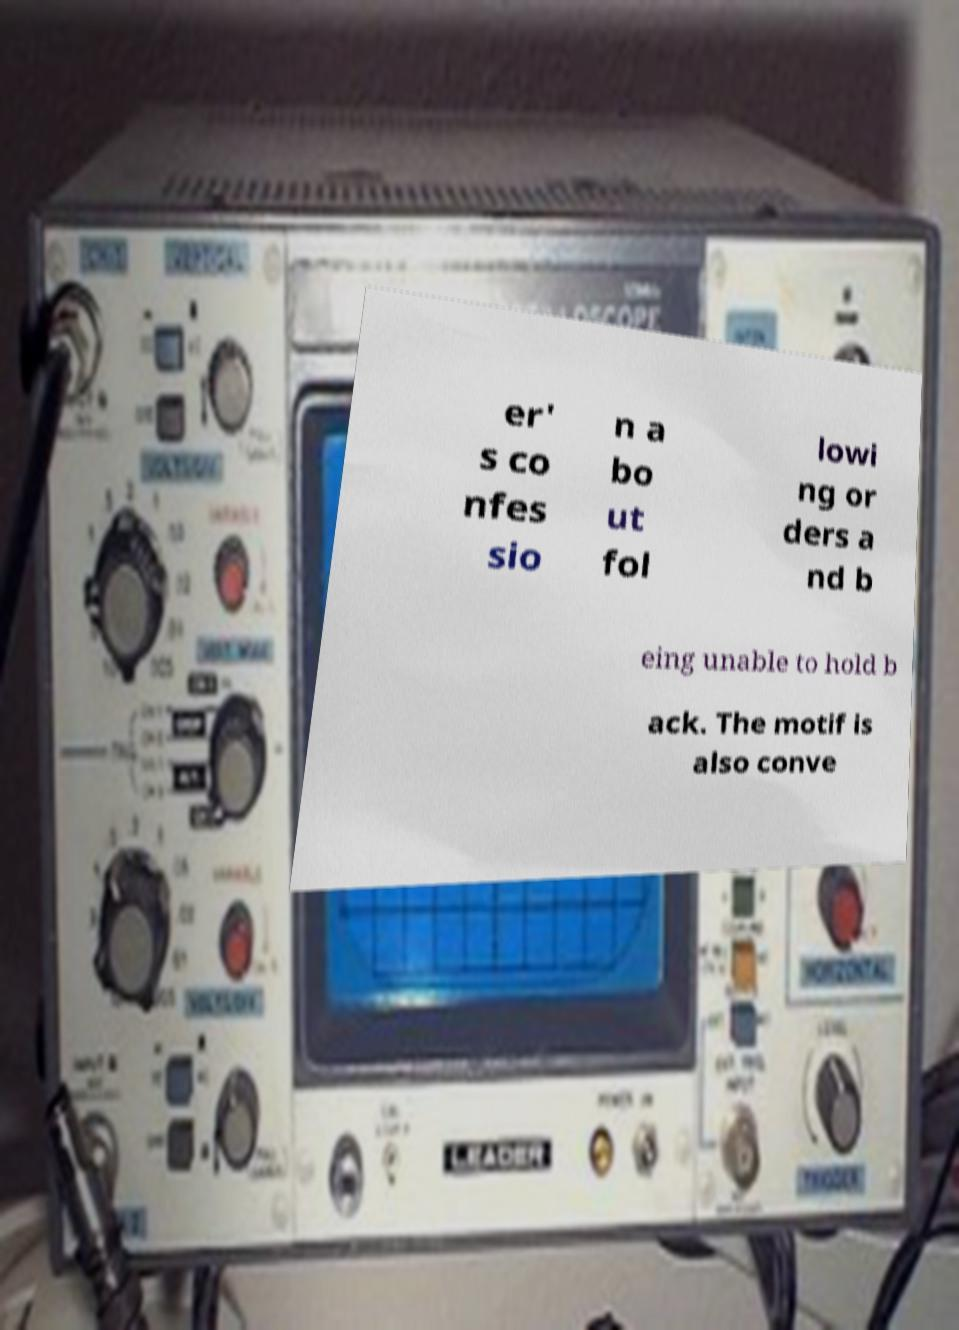What messages or text are displayed in this image? I need them in a readable, typed format. er' s co nfes sio n a bo ut fol lowi ng or ders a nd b eing unable to hold b ack. The motif is also conve 